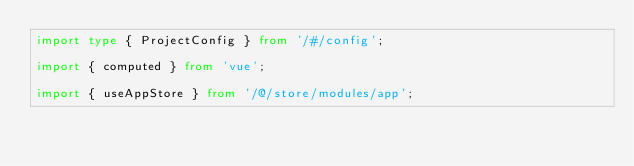<code> <loc_0><loc_0><loc_500><loc_500><_TypeScript_>import type { ProjectConfig } from '/#/config';

import { computed } from 'vue';

import { useAppStore } from '/@/store/modules/app';</code> 